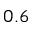Convert formula to latex. <formula><loc_0><loc_0><loc_500><loc_500>0 . 6</formula> 